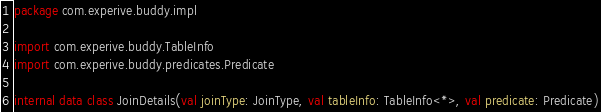<code> <loc_0><loc_0><loc_500><loc_500><_Kotlin_>package com.experive.buddy.impl

import com.experive.buddy.TableInfo
import com.experive.buddy.predicates.Predicate

internal data class JoinDetails(val joinType: JoinType, val tableInfo: TableInfo<*>, val predicate: Predicate)
</code> 